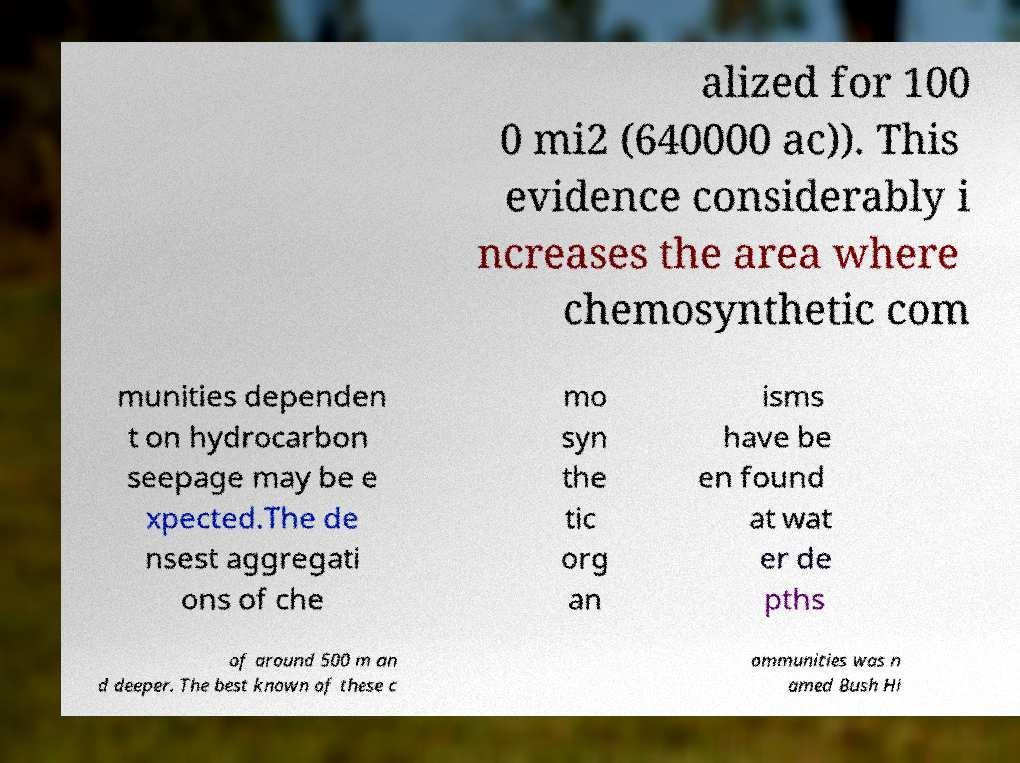Can you accurately transcribe the text from the provided image for me? alized for 100 0 mi2 (640000 ac)). This evidence considerably i ncreases the area where chemosynthetic com munities dependen t on hydrocarbon seepage may be e xpected.The de nsest aggregati ons of che mo syn the tic org an isms have be en found at wat er de pths of around 500 m an d deeper. The best known of these c ommunities was n amed Bush Hi 